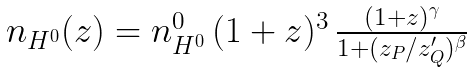Convert formula to latex. <formula><loc_0><loc_0><loc_500><loc_500>\begin{array} { c c } n _ { H ^ { 0 } } ( z ) = n ^ { 0 } _ { H ^ { 0 } } \, ( 1 + z ) ^ { 3 } \, { \frac { { ( 1 + z ) ^ { \gamma } } } { 1 + ( { { z _ { P } } / { z _ { Q } ^ { \prime } } } ) ^ { \beta } } } \end{array}</formula> 